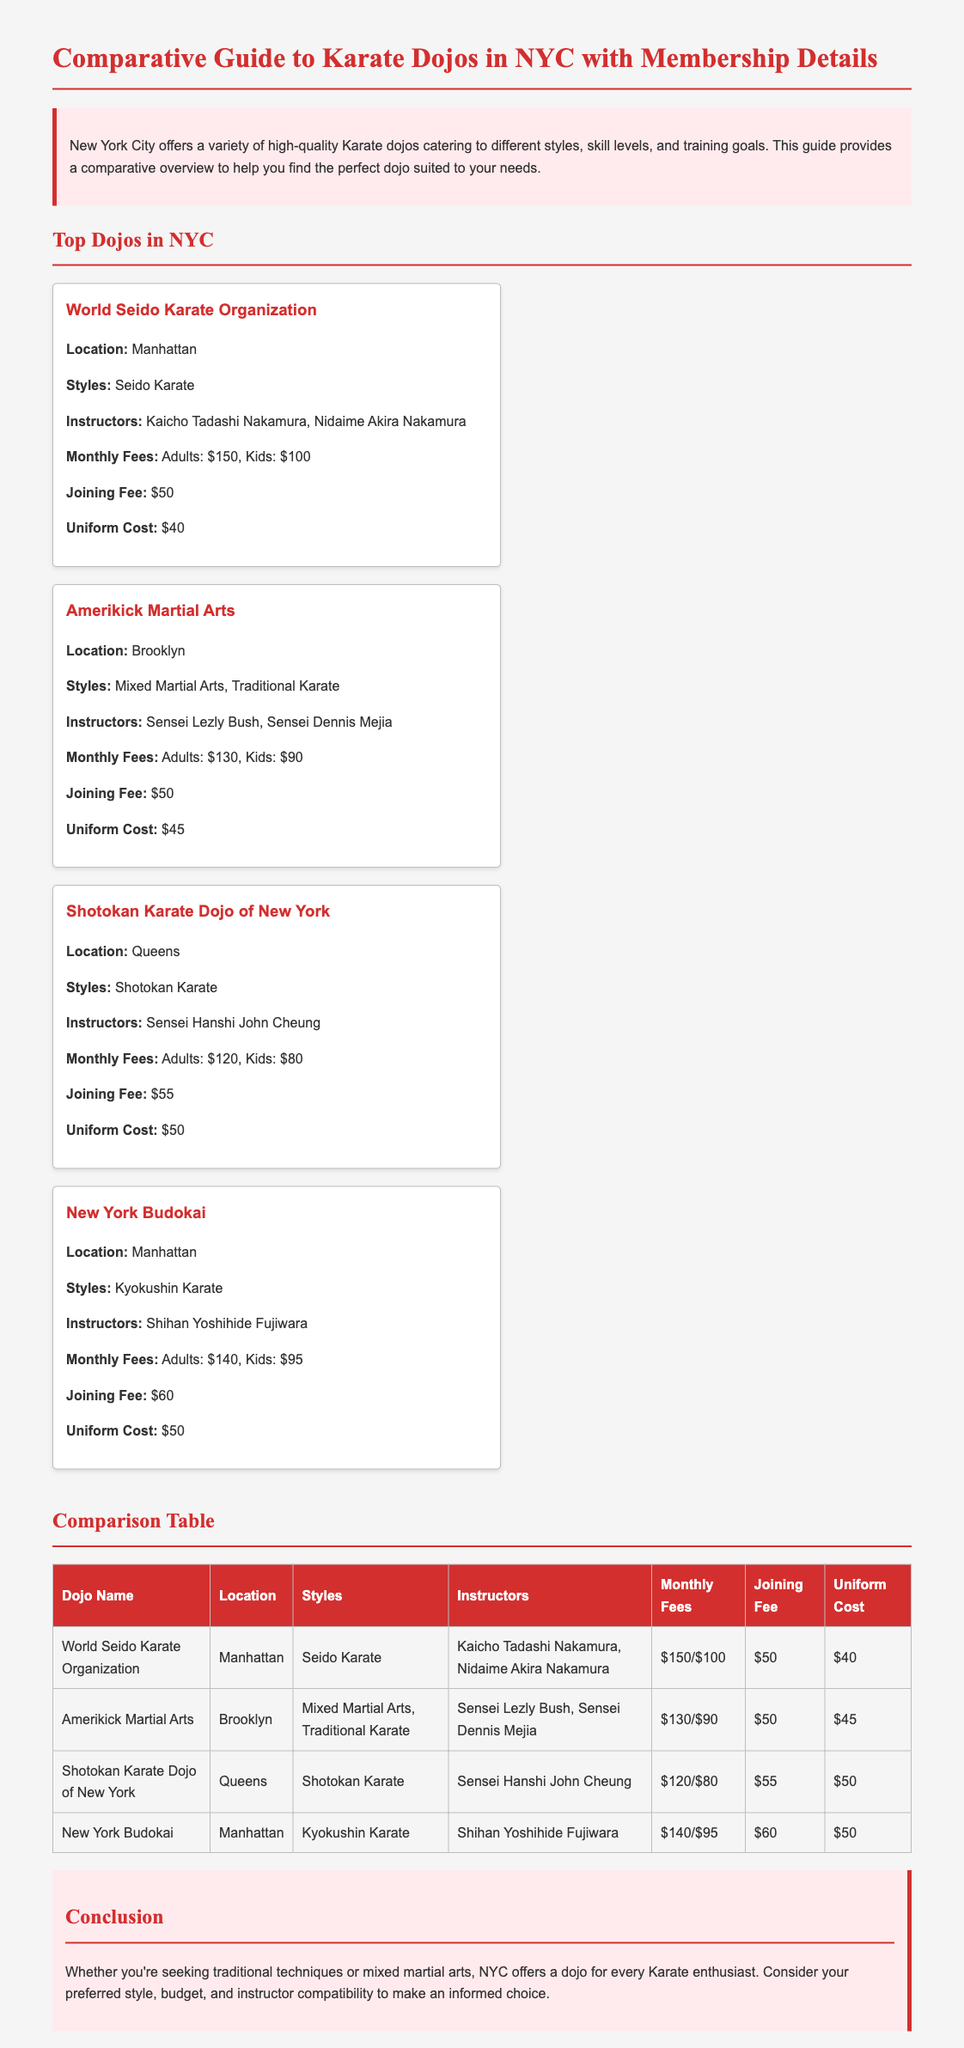What is the location of World Seido Karate Organization? The location is mentioned as Manhattan in the document.
Answer: Manhattan What is the monthly fee for kids at Shotokan Karate Dojo of New York? The document specifies the monthly fee for kids, which is $80.
Answer: $80 Who are the instructors at New York Budokai? The document lists Shihan Yoshihide Fujiwara as the instructor for New York Budokai.
Answer: Shihan Yoshihide Fujiwara What style does Amerikick Martial Arts teach? The document mentions that Amerikick Martial Arts teaches Mixed Martial Arts and Traditional Karate.
Answer: Mixed Martial Arts, Traditional Karate Which dojo has the highest monthly fee for adults? By comparing the fees, World Seido Karate Organization has the highest monthly fee for adults at $150.
Answer: World Seido Karate Organization What is the joining fee for Shotokan Karate Dojo of New York? The joining fee is explicitly listed in the document as $55.
Answer: $55 What is the uniform cost for Amerikick Martial Arts? The document states that the uniform cost for Amerikick Martial Arts is $45.
Answer: $45 Which dojo is located in Queens? The document identifies Shotokan Karate Dojo of New York as the dojo located in Queens.
Answer: Shotokan Karate Dojo of New York What are the monthly fees for adults at New York Budokai? The monthly fees for adults at New York Budokai are listed as $140.
Answer: $140 What is the primary style taught at World Seido Karate Organization? The document indicates that Seido Karate is the primary style taught there.
Answer: Seido Karate 